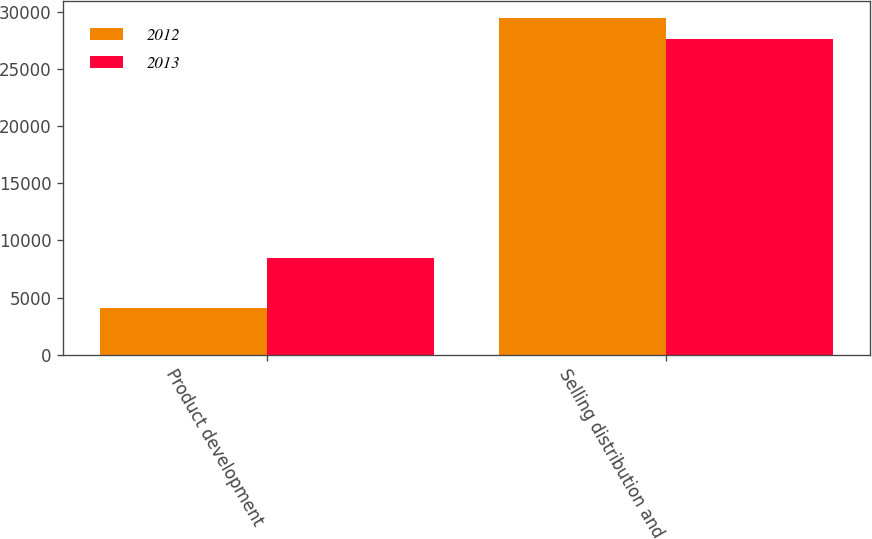Convert chart. <chart><loc_0><loc_0><loc_500><loc_500><stacked_bar_chart><ecel><fcel>Product development<fcel>Selling distribution and<nl><fcel>2012<fcel>4100<fcel>29448<nl><fcel>2013<fcel>8470<fcel>27576<nl></chart> 